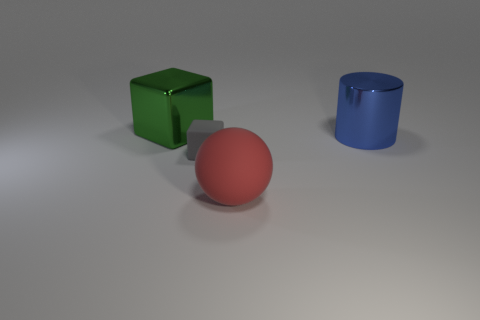What size is the object that is to the left of the red thing and in front of the cylinder?
Your answer should be very brief. Small. What is the color of the other thing that is the same shape as the gray matte object?
Give a very brief answer. Green. Is the number of large things right of the tiny cube greater than the number of large green shiny cubes that are on the left side of the matte sphere?
Your response must be concise. Yes. How many other things are the same shape as the large blue metal thing?
Make the answer very short. 0. There is a rubber object behind the red matte sphere; are there any matte spheres left of it?
Offer a terse response. No. How many yellow balls are there?
Provide a short and direct response. 0. Is the number of gray matte objects greater than the number of small cyan metallic balls?
Your answer should be very brief. Yes. Are there any other things of the same color as the sphere?
Offer a very short reply. No. What number of other things are the same size as the green block?
Make the answer very short. 2. There is a red sphere on the right side of the large object behind the large cylinder to the right of the green metallic block; what is its material?
Your response must be concise. Rubber. 